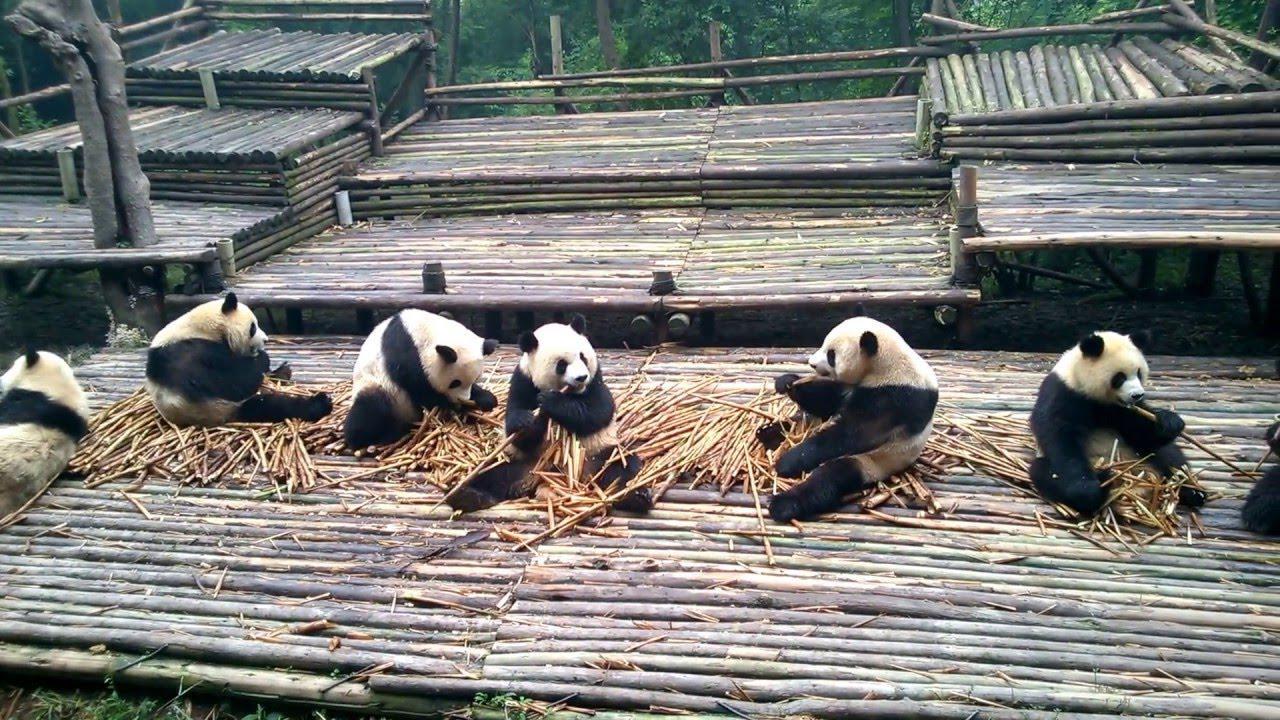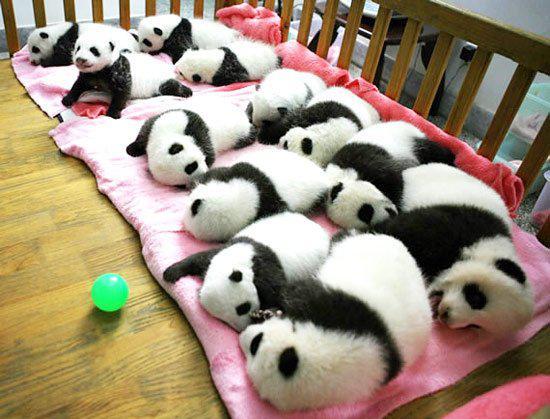The first image is the image on the left, the second image is the image on the right. Given the left and right images, does the statement "In one of the images there are three panda sitting and eating bamboo." hold true? Answer yes or no. No. 